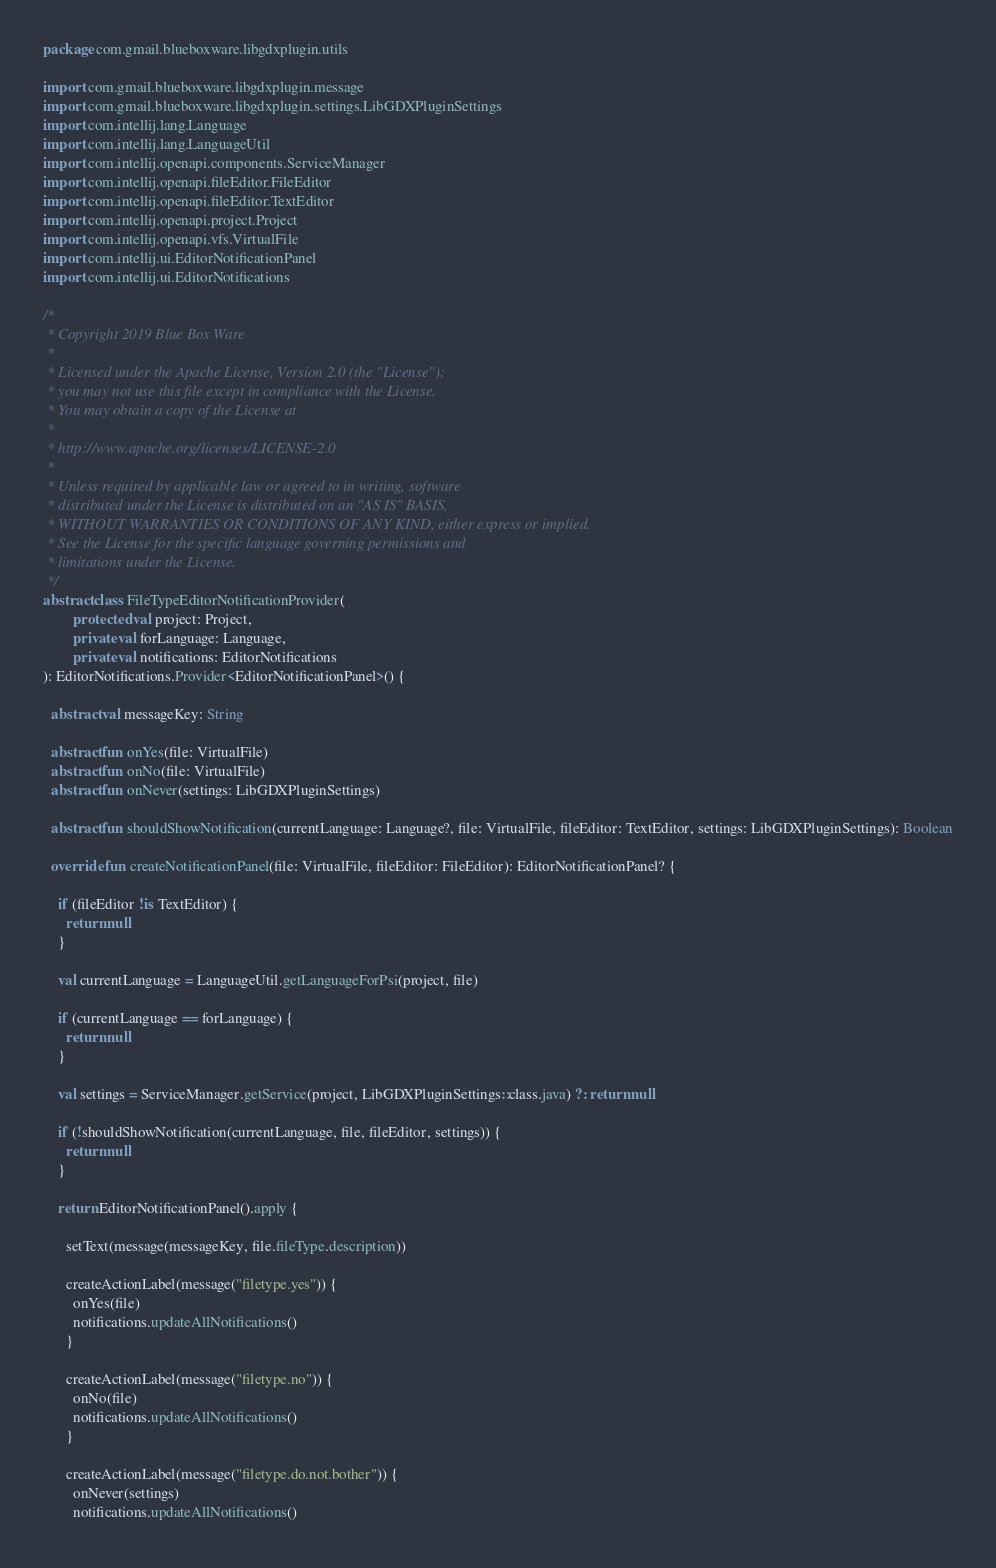<code> <loc_0><loc_0><loc_500><loc_500><_Kotlin_>package com.gmail.blueboxware.libgdxplugin.utils

import com.gmail.blueboxware.libgdxplugin.message
import com.gmail.blueboxware.libgdxplugin.settings.LibGDXPluginSettings
import com.intellij.lang.Language
import com.intellij.lang.LanguageUtil
import com.intellij.openapi.components.ServiceManager
import com.intellij.openapi.fileEditor.FileEditor
import com.intellij.openapi.fileEditor.TextEditor
import com.intellij.openapi.project.Project
import com.intellij.openapi.vfs.VirtualFile
import com.intellij.ui.EditorNotificationPanel
import com.intellij.ui.EditorNotifications

/*
 * Copyright 2019 Blue Box Ware
 *
 * Licensed under the Apache License, Version 2.0 (the "License");
 * you may not use this file except in compliance with the License.
 * You may obtain a copy of the License at
 *
 * http://www.apache.org/licenses/LICENSE-2.0
 *
 * Unless required by applicable law or agreed to in writing, software
 * distributed under the License is distributed on an "AS IS" BASIS,
 * WITHOUT WARRANTIES OR CONDITIONS OF ANY KIND, either express or implied.
 * See the License for the specific language governing permissions and
 * limitations under the License.
 */
abstract class FileTypeEditorNotificationProvider(
        protected val project: Project,
        private val forLanguage: Language,
        private val notifications: EditorNotifications
): EditorNotifications.Provider<EditorNotificationPanel>() {

  abstract val messageKey: String

  abstract fun onYes(file: VirtualFile)
  abstract fun onNo(file: VirtualFile)
  abstract fun onNever(settings: LibGDXPluginSettings)

  abstract fun shouldShowNotification(currentLanguage: Language?, file: VirtualFile, fileEditor: TextEditor, settings: LibGDXPluginSettings): Boolean

  override fun createNotificationPanel(file: VirtualFile, fileEditor: FileEditor): EditorNotificationPanel? {

    if (fileEditor !is TextEditor) {
      return null
    }

    val currentLanguage = LanguageUtil.getLanguageForPsi(project, file)

    if (currentLanguage == forLanguage) {
      return null
    }

    val settings = ServiceManager.getService(project, LibGDXPluginSettings::class.java) ?: return null

    if (!shouldShowNotification(currentLanguage, file, fileEditor, settings)) {
      return null
    }

    return EditorNotificationPanel().apply {

      setText(message(messageKey, file.fileType.description))

      createActionLabel(message("filetype.yes")) {
        onYes(file)
        notifications.updateAllNotifications()
      }

      createActionLabel(message("filetype.no")) {
        onNo(file)
        notifications.updateAllNotifications()
      }

      createActionLabel(message("filetype.do.not.bother")) {
        onNever(settings)
        notifications.updateAllNotifications()</code> 